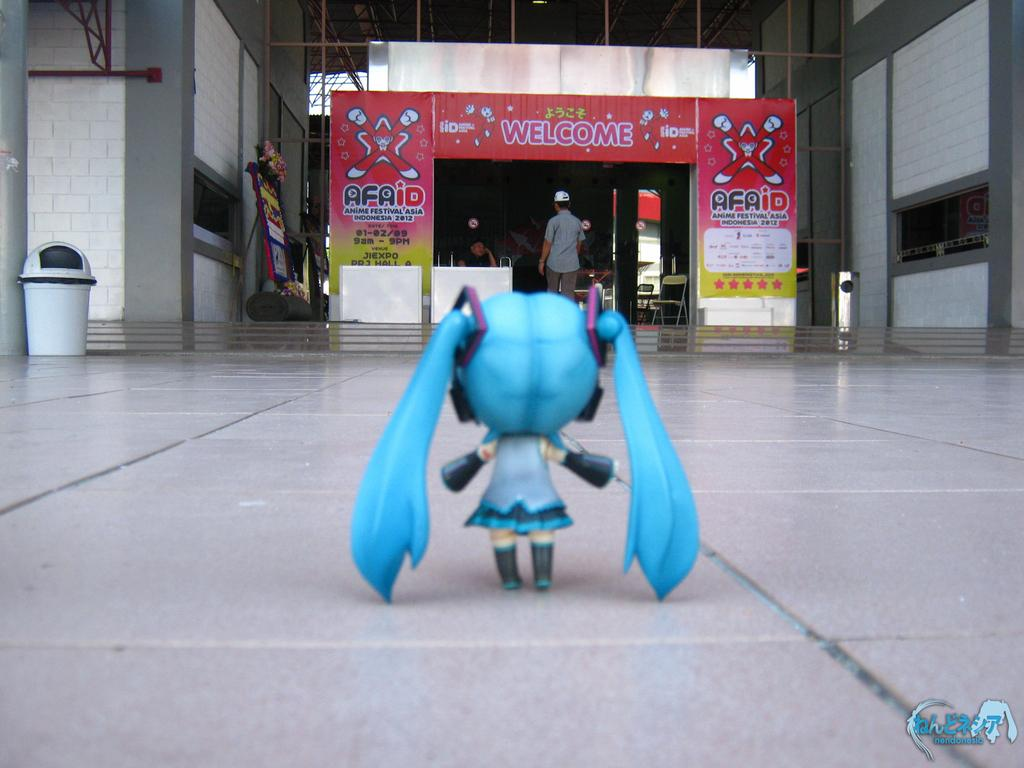What is on the floor in the image? There is a toy on the floor in the image. What is happening in the background of the image? There is a person entering a shop in the image. Can you hear the sound of the bell ringing as the person enters the shop in the image? There is no sound or reference to a bell in the image, so it is not possible to determine if it is ringing. 